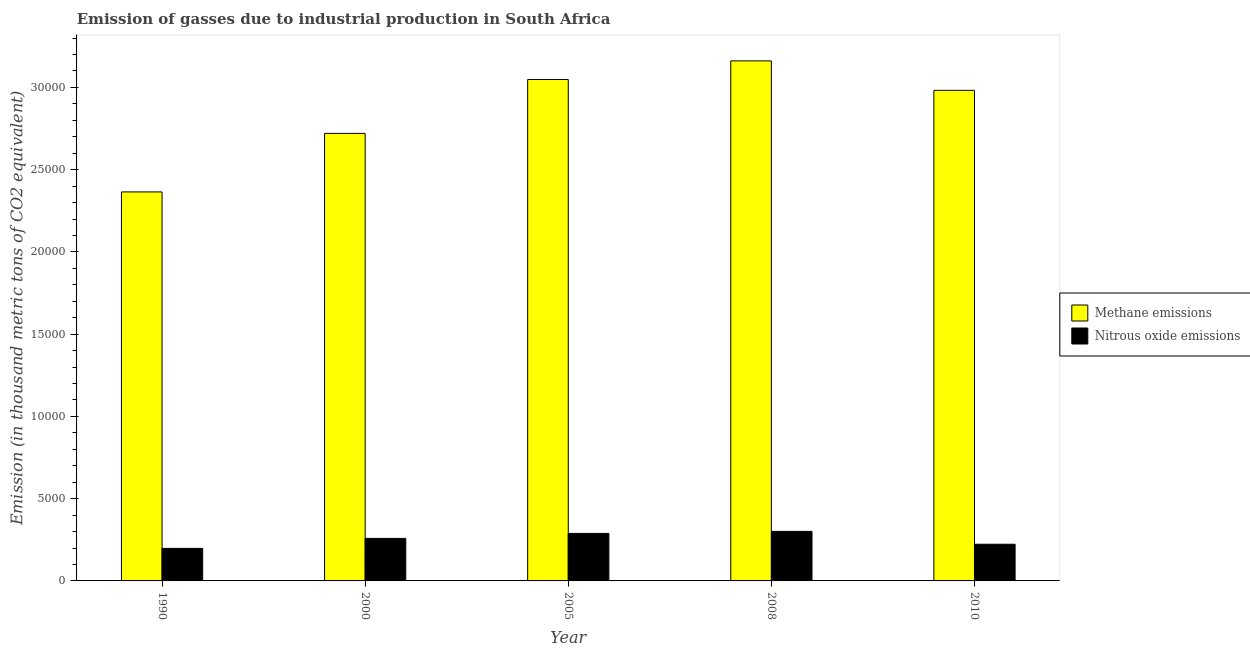How many different coloured bars are there?
Make the answer very short. 2. How many bars are there on the 4th tick from the right?
Ensure brevity in your answer.  2. What is the amount of nitrous oxide emissions in 2000?
Make the answer very short. 2584.7. Across all years, what is the maximum amount of methane emissions?
Provide a short and direct response. 3.16e+04. Across all years, what is the minimum amount of nitrous oxide emissions?
Make the answer very short. 1978.6. What is the total amount of methane emissions in the graph?
Make the answer very short. 1.43e+05. What is the difference between the amount of nitrous oxide emissions in 2000 and that in 2005?
Make the answer very short. -303.3. What is the difference between the amount of methane emissions in 1990 and the amount of nitrous oxide emissions in 2005?
Your answer should be compact. -6834.8. What is the average amount of nitrous oxide emissions per year?
Give a very brief answer. 2538.72. In how many years, is the amount of nitrous oxide emissions greater than 30000 thousand metric tons?
Your response must be concise. 0. What is the ratio of the amount of nitrous oxide emissions in 2005 to that in 2008?
Your answer should be very brief. 0.96. Is the difference between the amount of methane emissions in 1990 and 2005 greater than the difference between the amount of nitrous oxide emissions in 1990 and 2005?
Provide a succinct answer. No. What is the difference between the highest and the second highest amount of nitrous oxide emissions?
Your response must be concise. 124. What is the difference between the highest and the lowest amount of nitrous oxide emissions?
Provide a short and direct response. 1033.4. In how many years, is the amount of methane emissions greater than the average amount of methane emissions taken over all years?
Provide a short and direct response. 3. What does the 2nd bar from the left in 2005 represents?
Make the answer very short. Nitrous oxide emissions. What does the 1st bar from the right in 2000 represents?
Offer a very short reply. Nitrous oxide emissions. How many bars are there?
Your response must be concise. 10. Are all the bars in the graph horizontal?
Provide a succinct answer. No. How many years are there in the graph?
Your response must be concise. 5. How are the legend labels stacked?
Provide a succinct answer. Vertical. What is the title of the graph?
Make the answer very short. Emission of gasses due to industrial production in South Africa. What is the label or title of the Y-axis?
Ensure brevity in your answer.  Emission (in thousand metric tons of CO2 equivalent). What is the Emission (in thousand metric tons of CO2 equivalent) in Methane emissions in 1990?
Keep it short and to the point. 2.36e+04. What is the Emission (in thousand metric tons of CO2 equivalent) in Nitrous oxide emissions in 1990?
Ensure brevity in your answer.  1978.6. What is the Emission (in thousand metric tons of CO2 equivalent) in Methane emissions in 2000?
Ensure brevity in your answer.  2.72e+04. What is the Emission (in thousand metric tons of CO2 equivalent) in Nitrous oxide emissions in 2000?
Offer a terse response. 2584.7. What is the Emission (in thousand metric tons of CO2 equivalent) of Methane emissions in 2005?
Provide a succinct answer. 3.05e+04. What is the Emission (in thousand metric tons of CO2 equivalent) in Nitrous oxide emissions in 2005?
Offer a very short reply. 2888. What is the Emission (in thousand metric tons of CO2 equivalent) of Methane emissions in 2008?
Offer a terse response. 3.16e+04. What is the Emission (in thousand metric tons of CO2 equivalent) of Nitrous oxide emissions in 2008?
Provide a succinct answer. 3012. What is the Emission (in thousand metric tons of CO2 equivalent) of Methane emissions in 2010?
Provide a short and direct response. 2.98e+04. What is the Emission (in thousand metric tons of CO2 equivalent) of Nitrous oxide emissions in 2010?
Offer a very short reply. 2230.3. Across all years, what is the maximum Emission (in thousand metric tons of CO2 equivalent) in Methane emissions?
Give a very brief answer. 3.16e+04. Across all years, what is the maximum Emission (in thousand metric tons of CO2 equivalent) of Nitrous oxide emissions?
Offer a terse response. 3012. Across all years, what is the minimum Emission (in thousand metric tons of CO2 equivalent) of Methane emissions?
Your answer should be very brief. 2.36e+04. Across all years, what is the minimum Emission (in thousand metric tons of CO2 equivalent) of Nitrous oxide emissions?
Your answer should be compact. 1978.6. What is the total Emission (in thousand metric tons of CO2 equivalent) of Methane emissions in the graph?
Give a very brief answer. 1.43e+05. What is the total Emission (in thousand metric tons of CO2 equivalent) of Nitrous oxide emissions in the graph?
Your answer should be compact. 1.27e+04. What is the difference between the Emission (in thousand metric tons of CO2 equivalent) in Methane emissions in 1990 and that in 2000?
Your answer should be very brief. -3558.3. What is the difference between the Emission (in thousand metric tons of CO2 equivalent) in Nitrous oxide emissions in 1990 and that in 2000?
Give a very brief answer. -606.1. What is the difference between the Emission (in thousand metric tons of CO2 equivalent) in Methane emissions in 1990 and that in 2005?
Keep it short and to the point. -6834.8. What is the difference between the Emission (in thousand metric tons of CO2 equivalent) in Nitrous oxide emissions in 1990 and that in 2005?
Keep it short and to the point. -909.4. What is the difference between the Emission (in thousand metric tons of CO2 equivalent) of Methane emissions in 1990 and that in 2008?
Offer a terse response. -7965.9. What is the difference between the Emission (in thousand metric tons of CO2 equivalent) of Nitrous oxide emissions in 1990 and that in 2008?
Provide a short and direct response. -1033.4. What is the difference between the Emission (in thousand metric tons of CO2 equivalent) of Methane emissions in 1990 and that in 2010?
Give a very brief answer. -6175.2. What is the difference between the Emission (in thousand metric tons of CO2 equivalent) of Nitrous oxide emissions in 1990 and that in 2010?
Your answer should be very brief. -251.7. What is the difference between the Emission (in thousand metric tons of CO2 equivalent) in Methane emissions in 2000 and that in 2005?
Ensure brevity in your answer.  -3276.5. What is the difference between the Emission (in thousand metric tons of CO2 equivalent) in Nitrous oxide emissions in 2000 and that in 2005?
Ensure brevity in your answer.  -303.3. What is the difference between the Emission (in thousand metric tons of CO2 equivalent) in Methane emissions in 2000 and that in 2008?
Ensure brevity in your answer.  -4407.6. What is the difference between the Emission (in thousand metric tons of CO2 equivalent) of Nitrous oxide emissions in 2000 and that in 2008?
Your answer should be compact. -427.3. What is the difference between the Emission (in thousand metric tons of CO2 equivalent) in Methane emissions in 2000 and that in 2010?
Make the answer very short. -2616.9. What is the difference between the Emission (in thousand metric tons of CO2 equivalent) of Nitrous oxide emissions in 2000 and that in 2010?
Keep it short and to the point. 354.4. What is the difference between the Emission (in thousand metric tons of CO2 equivalent) in Methane emissions in 2005 and that in 2008?
Offer a very short reply. -1131.1. What is the difference between the Emission (in thousand metric tons of CO2 equivalent) of Nitrous oxide emissions in 2005 and that in 2008?
Ensure brevity in your answer.  -124. What is the difference between the Emission (in thousand metric tons of CO2 equivalent) in Methane emissions in 2005 and that in 2010?
Your answer should be very brief. 659.6. What is the difference between the Emission (in thousand metric tons of CO2 equivalent) in Nitrous oxide emissions in 2005 and that in 2010?
Make the answer very short. 657.7. What is the difference between the Emission (in thousand metric tons of CO2 equivalent) in Methane emissions in 2008 and that in 2010?
Offer a terse response. 1790.7. What is the difference between the Emission (in thousand metric tons of CO2 equivalent) in Nitrous oxide emissions in 2008 and that in 2010?
Give a very brief answer. 781.7. What is the difference between the Emission (in thousand metric tons of CO2 equivalent) of Methane emissions in 1990 and the Emission (in thousand metric tons of CO2 equivalent) of Nitrous oxide emissions in 2000?
Provide a short and direct response. 2.11e+04. What is the difference between the Emission (in thousand metric tons of CO2 equivalent) of Methane emissions in 1990 and the Emission (in thousand metric tons of CO2 equivalent) of Nitrous oxide emissions in 2005?
Offer a terse response. 2.08e+04. What is the difference between the Emission (in thousand metric tons of CO2 equivalent) of Methane emissions in 1990 and the Emission (in thousand metric tons of CO2 equivalent) of Nitrous oxide emissions in 2008?
Keep it short and to the point. 2.06e+04. What is the difference between the Emission (in thousand metric tons of CO2 equivalent) in Methane emissions in 1990 and the Emission (in thousand metric tons of CO2 equivalent) in Nitrous oxide emissions in 2010?
Keep it short and to the point. 2.14e+04. What is the difference between the Emission (in thousand metric tons of CO2 equivalent) of Methane emissions in 2000 and the Emission (in thousand metric tons of CO2 equivalent) of Nitrous oxide emissions in 2005?
Provide a succinct answer. 2.43e+04. What is the difference between the Emission (in thousand metric tons of CO2 equivalent) in Methane emissions in 2000 and the Emission (in thousand metric tons of CO2 equivalent) in Nitrous oxide emissions in 2008?
Offer a very short reply. 2.42e+04. What is the difference between the Emission (in thousand metric tons of CO2 equivalent) in Methane emissions in 2000 and the Emission (in thousand metric tons of CO2 equivalent) in Nitrous oxide emissions in 2010?
Make the answer very short. 2.50e+04. What is the difference between the Emission (in thousand metric tons of CO2 equivalent) in Methane emissions in 2005 and the Emission (in thousand metric tons of CO2 equivalent) in Nitrous oxide emissions in 2008?
Keep it short and to the point. 2.75e+04. What is the difference between the Emission (in thousand metric tons of CO2 equivalent) of Methane emissions in 2005 and the Emission (in thousand metric tons of CO2 equivalent) of Nitrous oxide emissions in 2010?
Your answer should be compact. 2.83e+04. What is the difference between the Emission (in thousand metric tons of CO2 equivalent) of Methane emissions in 2008 and the Emission (in thousand metric tons of CO2 equivalent) of Nitrous oxide emissions in 2010?
Keep it short and to the point. 2.94e+04. What is the average Emission (in thousand metric tons of CO2 equivalent) in Methane emissions per year?
Your answer should be very brief. 2.86e+04. What is the average Emission (in thousand metric tons of CO2 equivalent) of Nitrous oxide emissions per year?
Offer a terse response. 2538.72. In the year 1990, what is the difference between the Emission (in thousand metric tons of CO2 equivalent) in Methane emissions and Emission (in thousand metric tons of CO2 equivalent) in Nitrous oxide emissions?
Offer a very short reply. 2.17e+04. In the year 2000, what is the difference between the Emission (in thousand metric tons of CO2 equivalent) of Methane emissions and Emission (in thousand metric tons of CO2 equivalent) of Nitrous oxide emissions?
Provide a succinct answer. 2.46e+04. In the year 2005, what is the difference between the Emission (in thousand metric tons of CO2 equivalent) in Methane emissions and Emission (in thousand metric tons of CO2 equivalent) in Nitrous oxide emissions?
Give a very brief answer. 2.76e+04. In the year 2008, what is the difference between the Emission (in thousand metric tons of CO2 equivalent) in Methane emissions and Emission (in thousand metric tons of CO2 equivalent) in Nitrous oxide emissions?
Offer a terse response. 2.86e+04. In the year 2010, what is the difference between the Emission (in thousand metric tons of CO2 equivalent) of Methane emissions and Emission (in thousand metric tons of CO2 equivalent) of Nitrous oxide emissions?
Offer a terse response. 2.76e+04. What is the ratio of the Emission (in thousand metric tons of CO2 equivalent) of Methane emissions in 1990 to that in 2000?
Offer a terse response. 0.87. What is the ratio of the Emission (in thousand metric tons of CO2 equivalent) in Nitrous oxide emissions in 1990 to that in 2000?
Your answer should be compact. 0.77. What is the ratio of the Emission (in thousand metric tons of CO2 equivalent) of Methane emissions in 1990 to that in 2005?
Your answer should be compact. 0.78. What is the ratio of the Emission (in thousand metric tons of CO2 equivalent) in Nitrous oxide emissions in 1990 to that in 2005?
Provide a short and direct response. 0.69. What is the ratio of the Emission (in thousand metric tons of CO2 equivalent) in Methane emissions in 1990 to that in 2008?
Offer a terse response. 0.75. What is the ratio of the Emission (in thousand metric tons of CO2 equivalent) of Nitrous oxide emissions in 1990 to that in 2008?
Offer a terse response. 0.66. What is the ratio of the Emission (in thousand metric tons of CO2 equivalent) in Methane emissions in 1990 to that in 2010?
Make the answer very short. 0.79. What is the ratio of the Emission (in thousand metric tons of CO2 equivalent) of Nitrous oxide emissions in 1990 to that in 2010?
Your answer should be very brief. 0.89. What is the ratio of the Emission (in thousand metric tons of CO2 equivalent) in Methane emissions in 2000 to that in 2005?
Keep it short and to the point. 0.89. What is the ratio of the Emission (in thousand metric tons of CO2 equivalent) of Nitrous oxide emissions in 2000 to that in 2005?
Keep it short and to the point. 0.9. What is the ratio of the Emission (in thousand metric tons of CO2 equivalent) of Methane emissions in 2000 to that in 2008?
Keep it short and to the point. 0.86. What is the ratio of the Emission (in thousand metric tons of CO2 equivalent) in Nitrous oxide emissions in 2000 to that in 2008?
Make the answer very short. 0.86. What is the ratio of the Emission (in thousand metric tons of CO2 equivalent) of Methane emissions in 2000 to that in 2010?
Your response must be concise. 0.91. What is the ratio of the Emission (in thousand metric tons of CO2 equivalent) of Nitrous oxide emissions in 2000 to that in 2010?
Provide a short and direct response. 1.16. What is the ratio of the Emission (in thousand metric tons of CO2 equivalent) in Methane emissions in 2005 to that in 2008?
Offer a terse response. 0.96. What is the ratio of the Emission (in thousand metric tons of CO2 equivalent) of Nitrous oxide emissions in 2005 to that in 2008?
Ensure brevity in your answer.  0.96. What is the ratio of the Emission (in thousand metric tons of CO2 equivalent) in Methane emissions in 2005 to that in 2010?
Offer a terse response. 1.02. What is the ratio of the Emission (in thousand metric tons of CO2 equivalent) in Nitrous oxide emissions in 2005 to that in 2010?
Keep it short and to the point. 1.29. What is the ratio of the Emission (in thousand metric tons of CO2 equivalent) of Methane emissions in 2008 to that in 2010?
Offer a very short reply. 1.06. What is the ratio of the Emission (in thousand metric tons of CO2 equivalent) in Nitrous oxide emissions in 2008 to that in 2010?
Provide a succinct answer. 1.35. What is the difference between the highest and the second highest Emission (in thousand metric tons of CO2 equivalent) in Methane emissions?
Provide a succinct answer. 1131.1. What is the difference between the highest and the second highest Emission (in thousand metric tons of CO2 equivalent) of Nitrous oxide emissions?
Make the answer very short. 124. What is the difference between the highest and the lowest Emission (in thousand metric tons of CO2 equivalent) of Methane emissions?
Provide a short and direct response. 7965.9. What is the difference between the highest and the lowest Emission (in thousand metric tons of CO2 equivalent) in Nitrous oxide emissions?
Make the answer very short. 1033.4. 